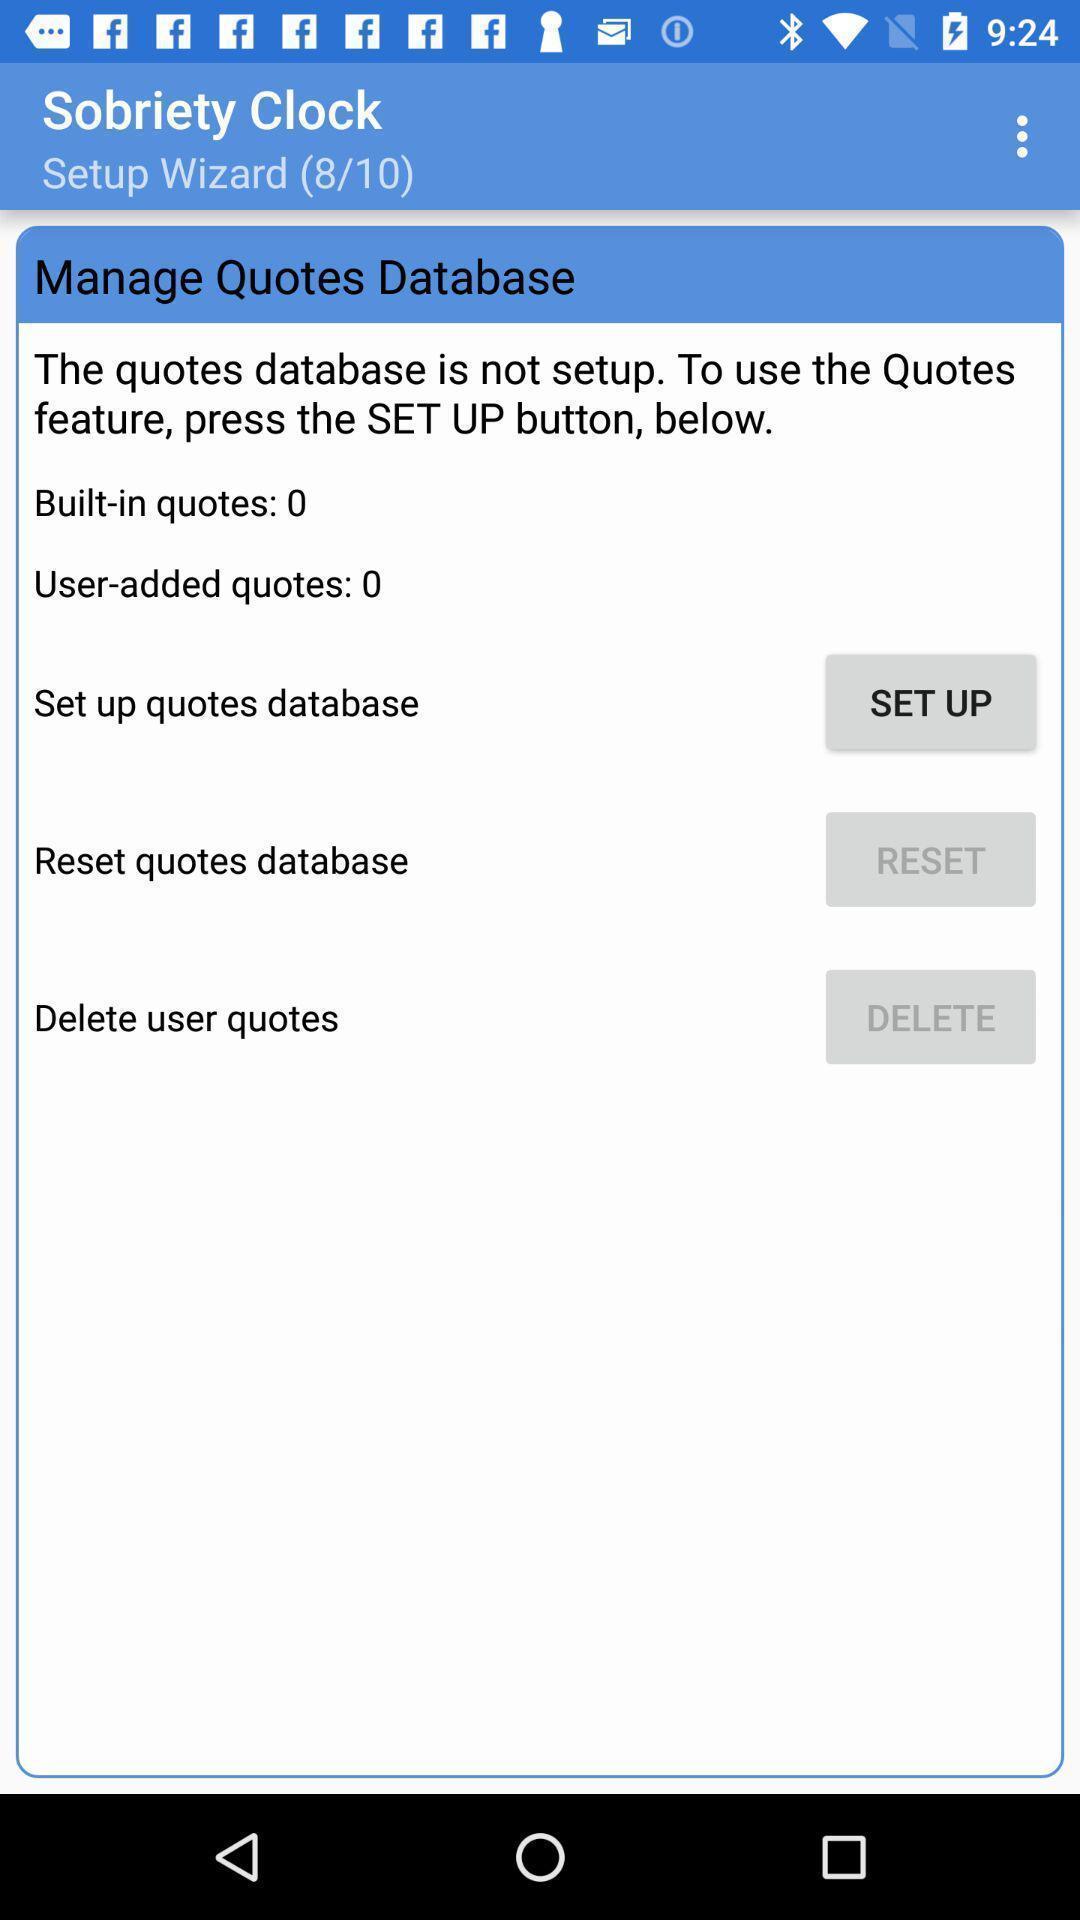Tell me about the visual elements in this screen capture. Quotes data base in the app. 